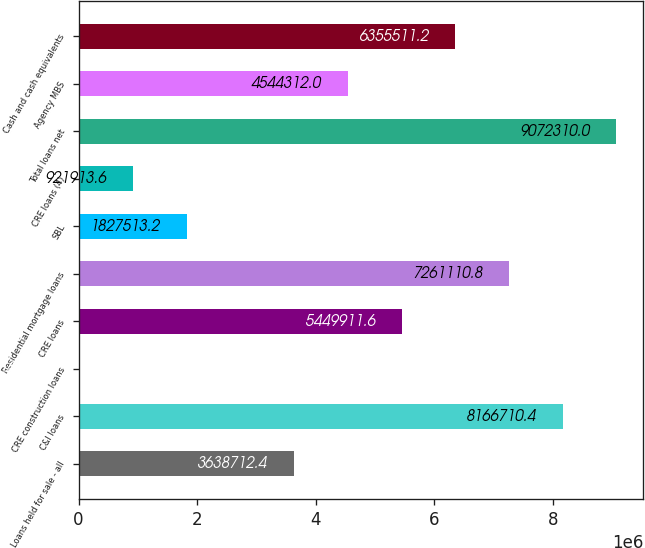<chart> <loc_0><loc_0><loc_500><loc_500><bar_chart><fcel>Loans held for sale - all<fcel>C&I loans<fcel>CRE construction loans<fcel>CRE loans<fcel>Residential mortgage loans<fcel>SBL<fcel>CRE loans (4)<fcel>Total loans net<fcel>Agency MBS<fcel>Cash and cash equivalents<nl><fcel>3.63871e+06<fcel>8.16671e+06<fcel>16314<fcel>5.44991e+06<fcel>7.26111e+06<fcel>1.82751e+06<fcel>921914<fcel>9.07231e+06<fcel>4.54431e+06<fcel>6.35551e+06<nl></chart> 